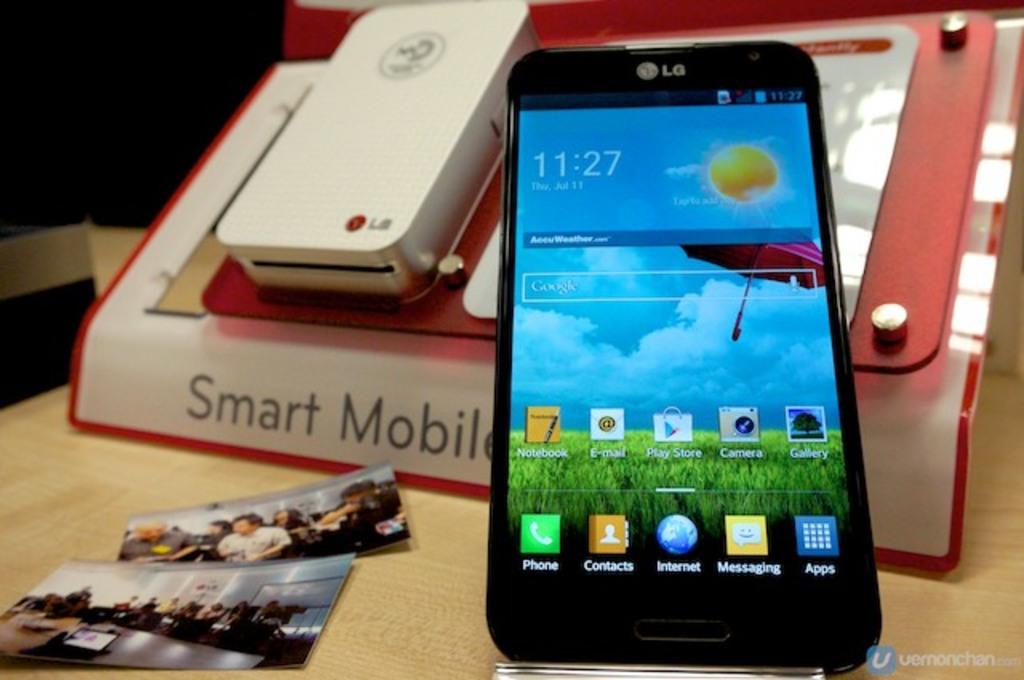What brand of smartphone is this?
Offer a terse response. Lg. What time does the phone say it is?
Provide a short and direct response. 11:27. 